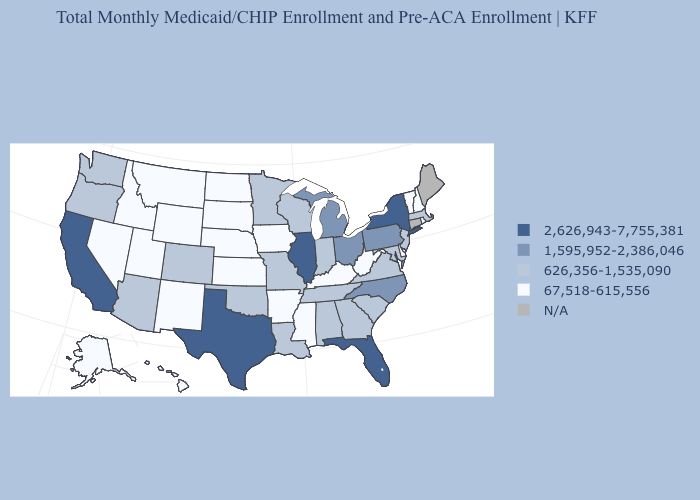Name the states that have a value in the range 626,356-1,535,090?
Answer briefly. Alabama, Arizona, Colorado, Georgia, Indiana, Louisiana, Maryland, Massachusetts, Minnesota, Missouri, New Jersey, Oklahoma, Oregon, South Carolina, Tennessee, Virginia, Washington, Wisconsin. Which states hav the highest value in the MidWest?
Write a very short answer. Illinois. Does New York have the highest value in the Northeast?
Write a very short answer. Yes. What is the value of Maine?
Short answer required. N/A. Which states have the lowest value in the USA?
Be succinct. Alaska, Arkansas, Delaware, Hawaii, Idaho, Iowa, Kansas, Kentucky, Mississippi, Montana, Nebraska, Nevada, New Hampshire, New Mexico, North Dakota, Rhode Island, South Dakota, Utah, Vermont, West Virginia, Wyoming. Among the states that border Georgia , which have the lowest value?
Concise answer only. Alabama, South Carolina, Tennessee. Which states have the lowest value in the MidWest?
Short answer required. Iowa, Kansas, Nebraska, North Dakota, South Dakota. Name the states that have a value in the range 1,595,952-2,386,046?
Be succinct. Michigan, North Carolina, Ohio, Pennsylvania. What is the value of Virginia?
Concise answer only. 626,356-1,535,090. Which states hav the highest value in the Northeast?
Short answer required. New York. What is the value of Arkansas?
Answer briefly. 67,518-615,556. Among the states that border Montana , which have the lowest value?
Give a very brief answer. Idaho, North Dakota, South Dakota, Wyoming. Name the states that have a value in the range 626,356-1,535,090?
Short answer required. Alabama, Arizona, Colorado, Georgia, Indiana, Louisiana, Maryland, Massachusetts, Minnesota, Missouri, New Jersey, Oklahoma, Oregon, South Carolina, Tennessee, Virginia, Washington, Wisconsin. Does the first symbol in the legend represent the smallest category?
Write a very short answer. No. 